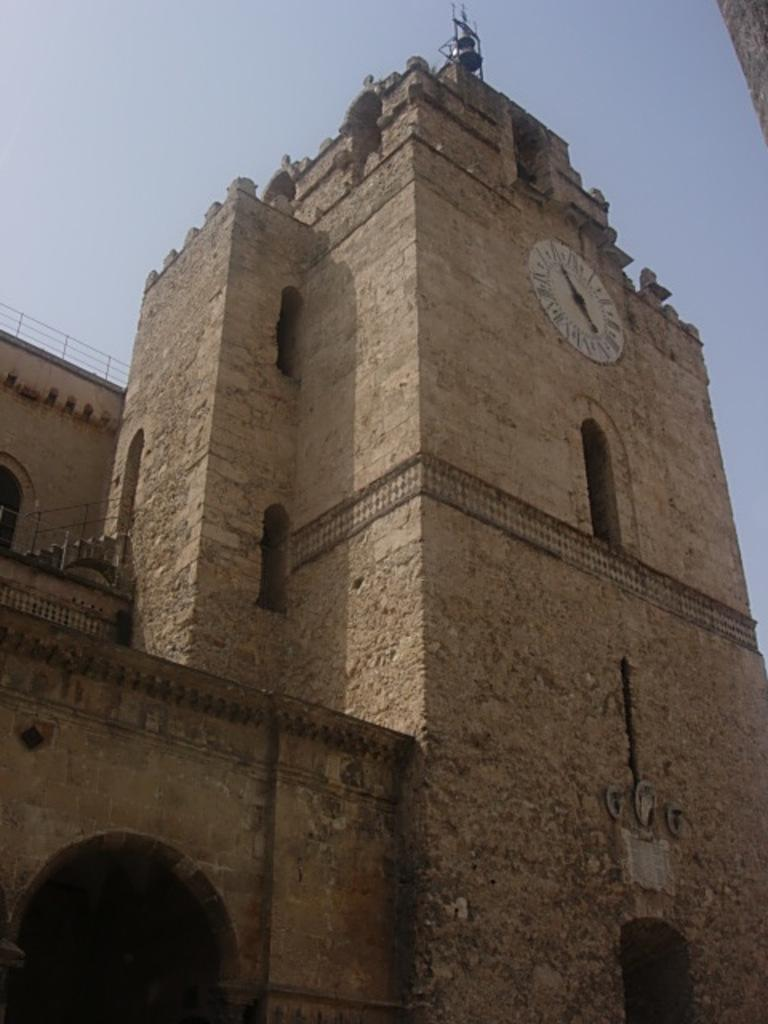What is the main subject in the foreground of the image? The main subjects in the foreground of the image are a wall of a building, an arch, stairs, and a railing. What can be seen on the wall in the foreground of the image? There is a clock on the wall in the foreground of the image. What architectural feature is present in the foreground of the image? The arch is an architectural feature present in the foreground of the image. What is visible at the top of the image? The sky is visible at the top of the image. How does the goose control the flow of traffic in the image? There is no goose present in the image, so it cannot control the flow of traffic. What type of curve is visible in the image? There is no curve visible in the image; the main subjects are a wall, an arch, stairs, and a railing. 